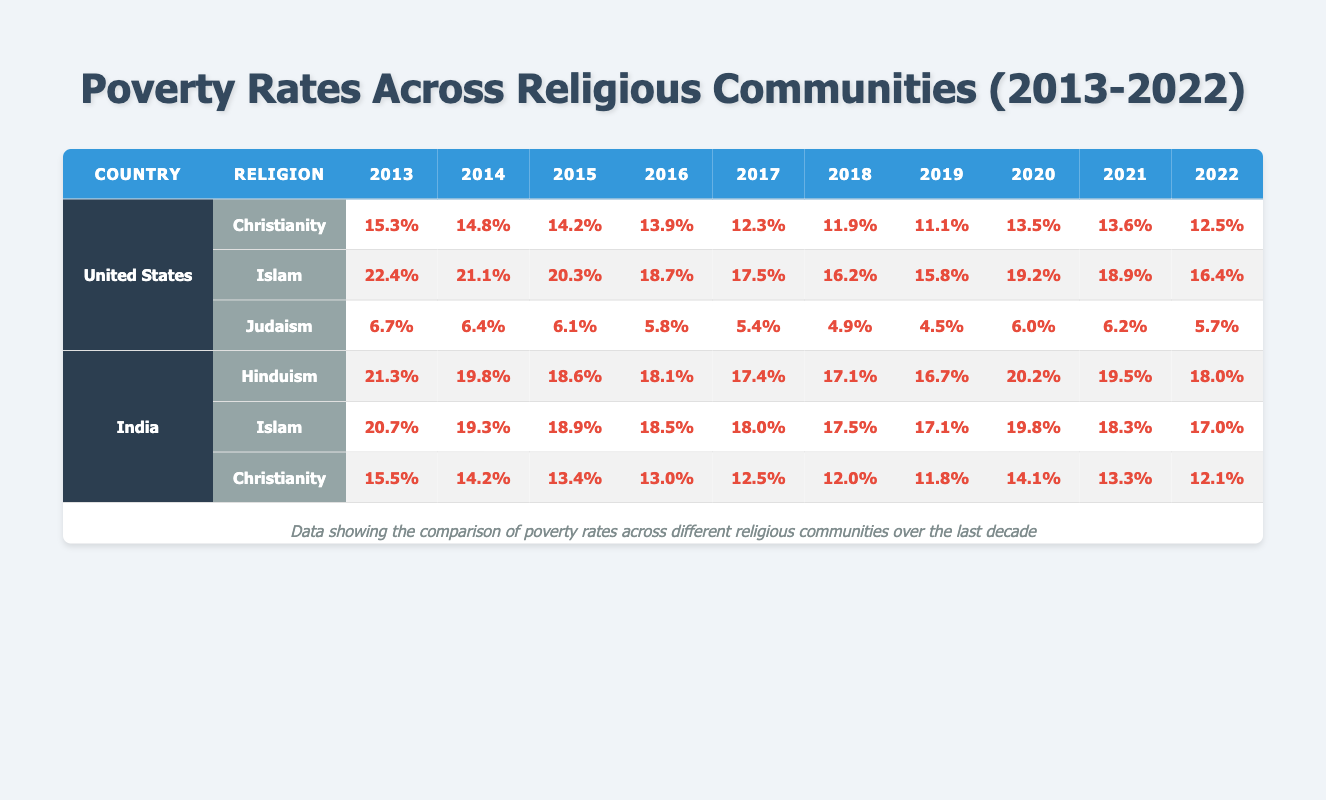What was the poverty rate for Islam in the United States in 2015? According to the table, in 2015, the poverty rate for Islam in the United States was recorded as 20.3%.
Answer: 20.3% Which religion had the lowest poverty rate in the United States in 2022? The table shows that in 2022, Judaism had the lowest poverty rate in the United States at 5.7%.
Answer: 5.7% What was the highest poverty rate for Hinduism in India during the last decade? Reviewing the data, Hinduism had the highest poverty rate in India in 2013 at 21.3%.
Answer: 21.3% In which year did Christianity in India have a poverty rate that was closest to 12%? Looking at the years for Christianity in India, in 2018, the poverty rate was 12.0%, the closest to 12%.
Answer: 12.0% True or False: The poverty rate for Judaism in the United States decreased in every year from 2013 to 2019. By examining the values, the poverty rate for Judaism decreased in the years listed from 2013 to 2019, confirming it as true.
Answer: True What was the difference between the poverty rates of Islam in the United States and India in 2020? The poverty rate for Islam in the United States in 2020 was 19.2%, and in India, it was 19.8%. The difference is 19.8 - 19.2 = 0.6%.
Answer: 0.6% In which country did Christianity experience the largest decrease in poverty rate from 2013 to 2022? Analyzing the data, Christianity in the United States decreased from 15.3% in 2013 to 12.5% in 2022, a decrease of 2.8%. In India, Christianity decreased from 15.5% to 12.1%, a decrease of 3.4%. Thus, India experienced the largest decrease.
Answer: India What were the poverty trends for Islam in the United States over the last decade? Observing the rates from 2013 through 2022, there was an initial decrease from 22.4% to 16.2% from 2013 to 2019, but rates increased in 2020 and 2021 before slightly decreasing again to 16.4% in 2022, showing fluctuations rather than a steady trend.
Answer: Fluctuating trends What was the average poverty rate for Hinduism in India across the last decade? The values for the poverty rates for Hinduism in India from 2013 to 2022 are 21.3, 19.8, 18.6, 18.1, 17.4, 17.1, 16.7, 20.2, 19.5, and 18.0. The sum of these rates is 184.7 and there are 10 data points, so the average is 184.7 / 10 = 18.47%.
Answer: 18.47% 